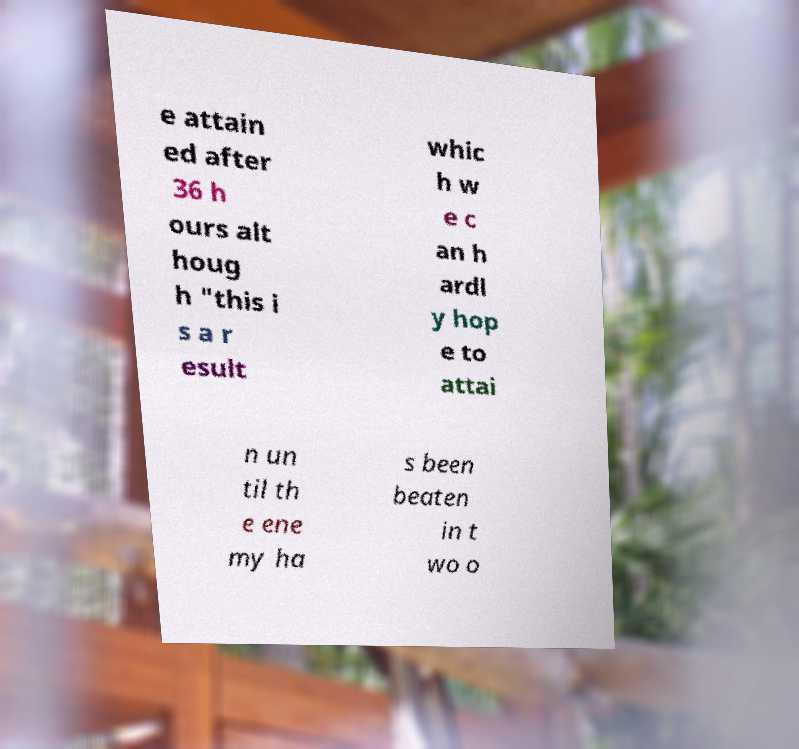There's text embedded in this image that I need extracted. Can you transcribe it verbatim? e attain ed after 36 h ours alt houg h "this i s a r esult whic h w e c an h ardl y hop e to attai n un til th e ene my ha s been beaten in t wo o 